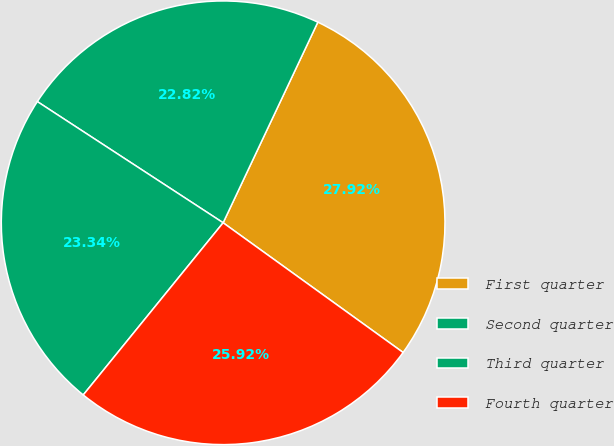Convert chart. <chart><loc_0><loc_0><loc_500><loc_500><pie_chart><fcel>First quarter<fcel>Second quarter<fcel>Third quarter<fcel>Fourth quarter<nl><fcel>27.92%<fcel>22.82%<fcel>23.34%<fcel>25.92%<nl></chart> 